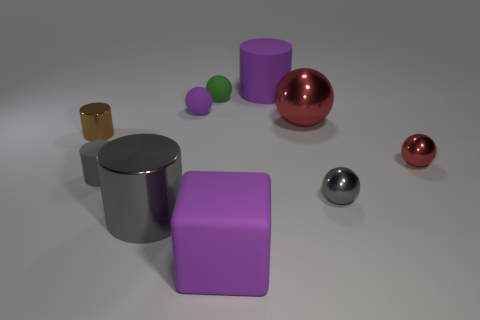Subtract 2 spheres. How many spheres are left? 3 Subtract all green spheres. How many spheres are left? 4 Subtract all brown balls. Subtract all brown cylinders. How many balls are left? 5 Subtract all cylinders. How many objects are left? 6 Add 2 large purple cubes. How many large purple cubes exist? 3 Subtract 1 red spheres. How many objects are left? 9 Subtract all balls. Subtract all red objects. How many objects are left? 3 Add 4 big cylinders. How many big cylinders are left? 6 